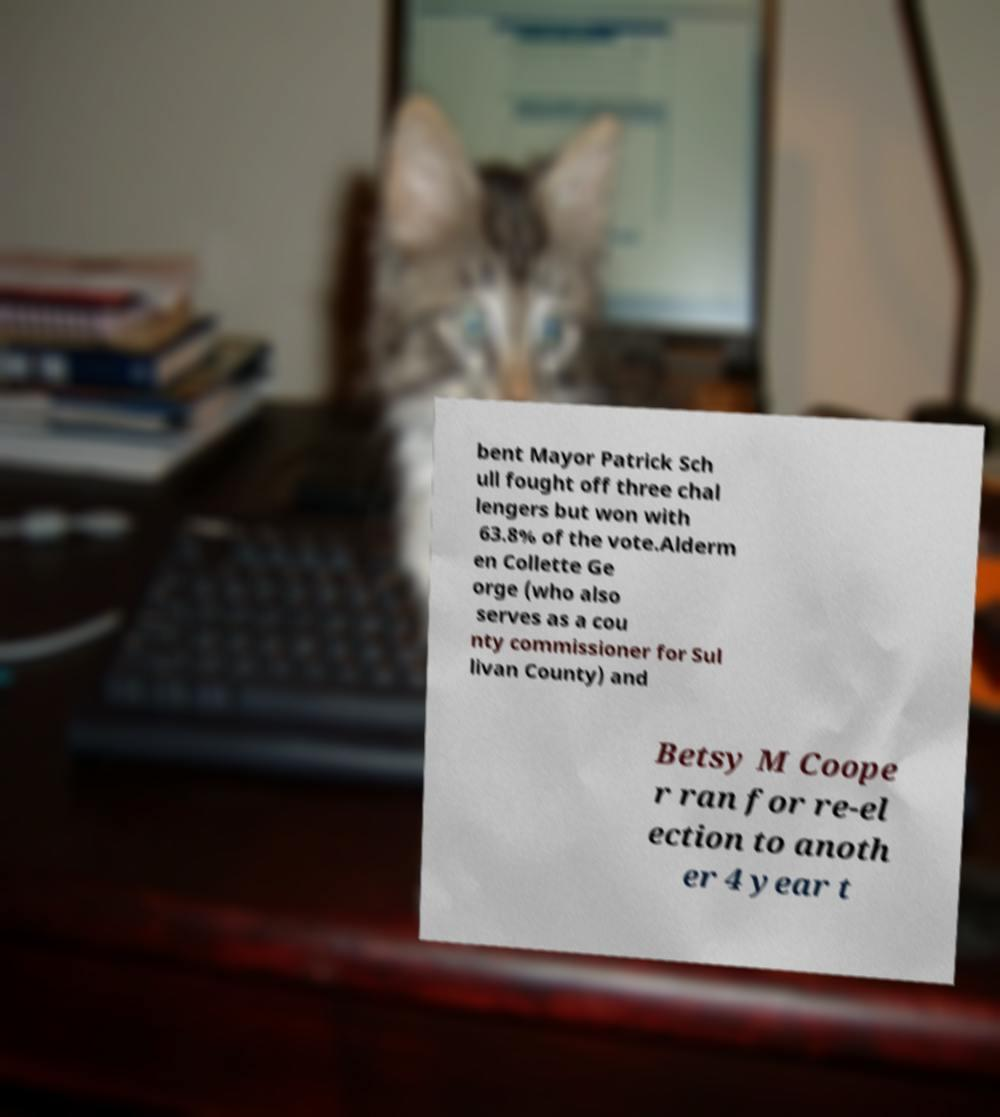Could you extract and type out the text from this image? bent Mayor Patrick Sch ull fought off three chal lengers but won with 63.8% of the vote.Alderm en Collette Ge orge (who also serves as a cou nty commissioner for Sul livan County) and Betsy M Coope r ran for re-el ection to anoth er 4 year t 